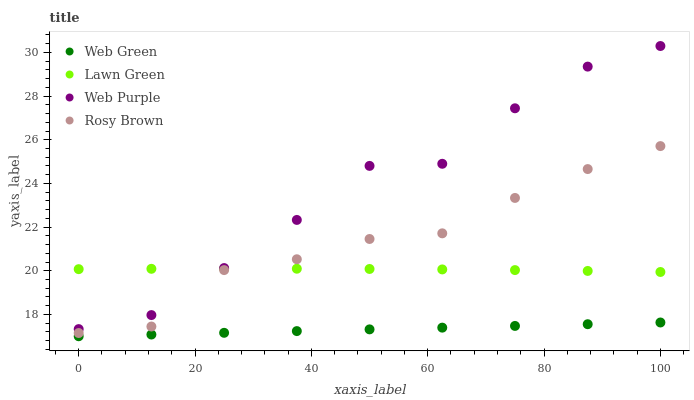Does Web Green have the minimum area under the curve?
Answer yes or no. Yes. Does Web Purple have the maximum area under the curve?
Answer yes or no. Yes. Does Rosy Brown have the minimum area under the curve?
Answer yes or no. No. Does Rosy Brown have the maximum area under the curve?
Answer yes or no. No. Is Web Green the smoothest?
Answer yes or no. Yes. Is Web Purple the roughest?
Answer yes or no. Yes. Is Rosy Brown the smoothest?
Answer yes or no. No. Is Rosy Brown the roughest?
Answer yes or no. No. Does Web Green have the lowest value?
Answer yes or no. Yes. Does Web Purple have the lowest value?
Answer yes or no. No. Does Web Purple have the highest value?
Answer yes or no. Yes. Does Rosy Brown have the highest value?
Answer yes or no. No. Is Web Green less than Web Purple?
Answer yes or no. Yes. Is Rosy Brown greater than Web Green?
Answer yes or no. Yes. Does Web Purple intersect Lawn Green?
Answer yes or no. Yes. Is Web Purple less than Lawn Green?
Answer yes or no. No. Is Web Purple greater than Lawn Green?
Answer yes or no. No. Does Web Green intersect Web Purple?
Answer yes or no. No. 